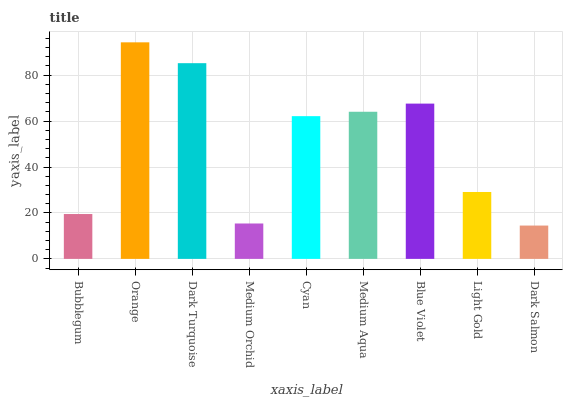Is Dark Salmon the minimum?
Answer yes or no. Yes. Is Orange the maximum?
Answer yes or no. Yes. Is Dark Turquoise the minimum?
Answer yes or no. No. Is Dark Turquoise the maximum?
Answer yes or no. No. Is Orange greater than Dark Turquoise?
Answer yes or no. Yes. Is Dark Turquoise less than Orange?
Answer yes or no. Yes. Is Dark Turquoise greater than Orange?
Answer yes or no. No. Is Orange less than Dark Turquoise?
Answer yes or no. No. Is Cyan the high median?
Answer yes or no. Yes. Is Cyan the low median?
Answer yes or no. Yes. Is Medium Orchid the high median?
Answer yes or no. No. Is Dark Salmon the low median?
Answer yes or no. No. 